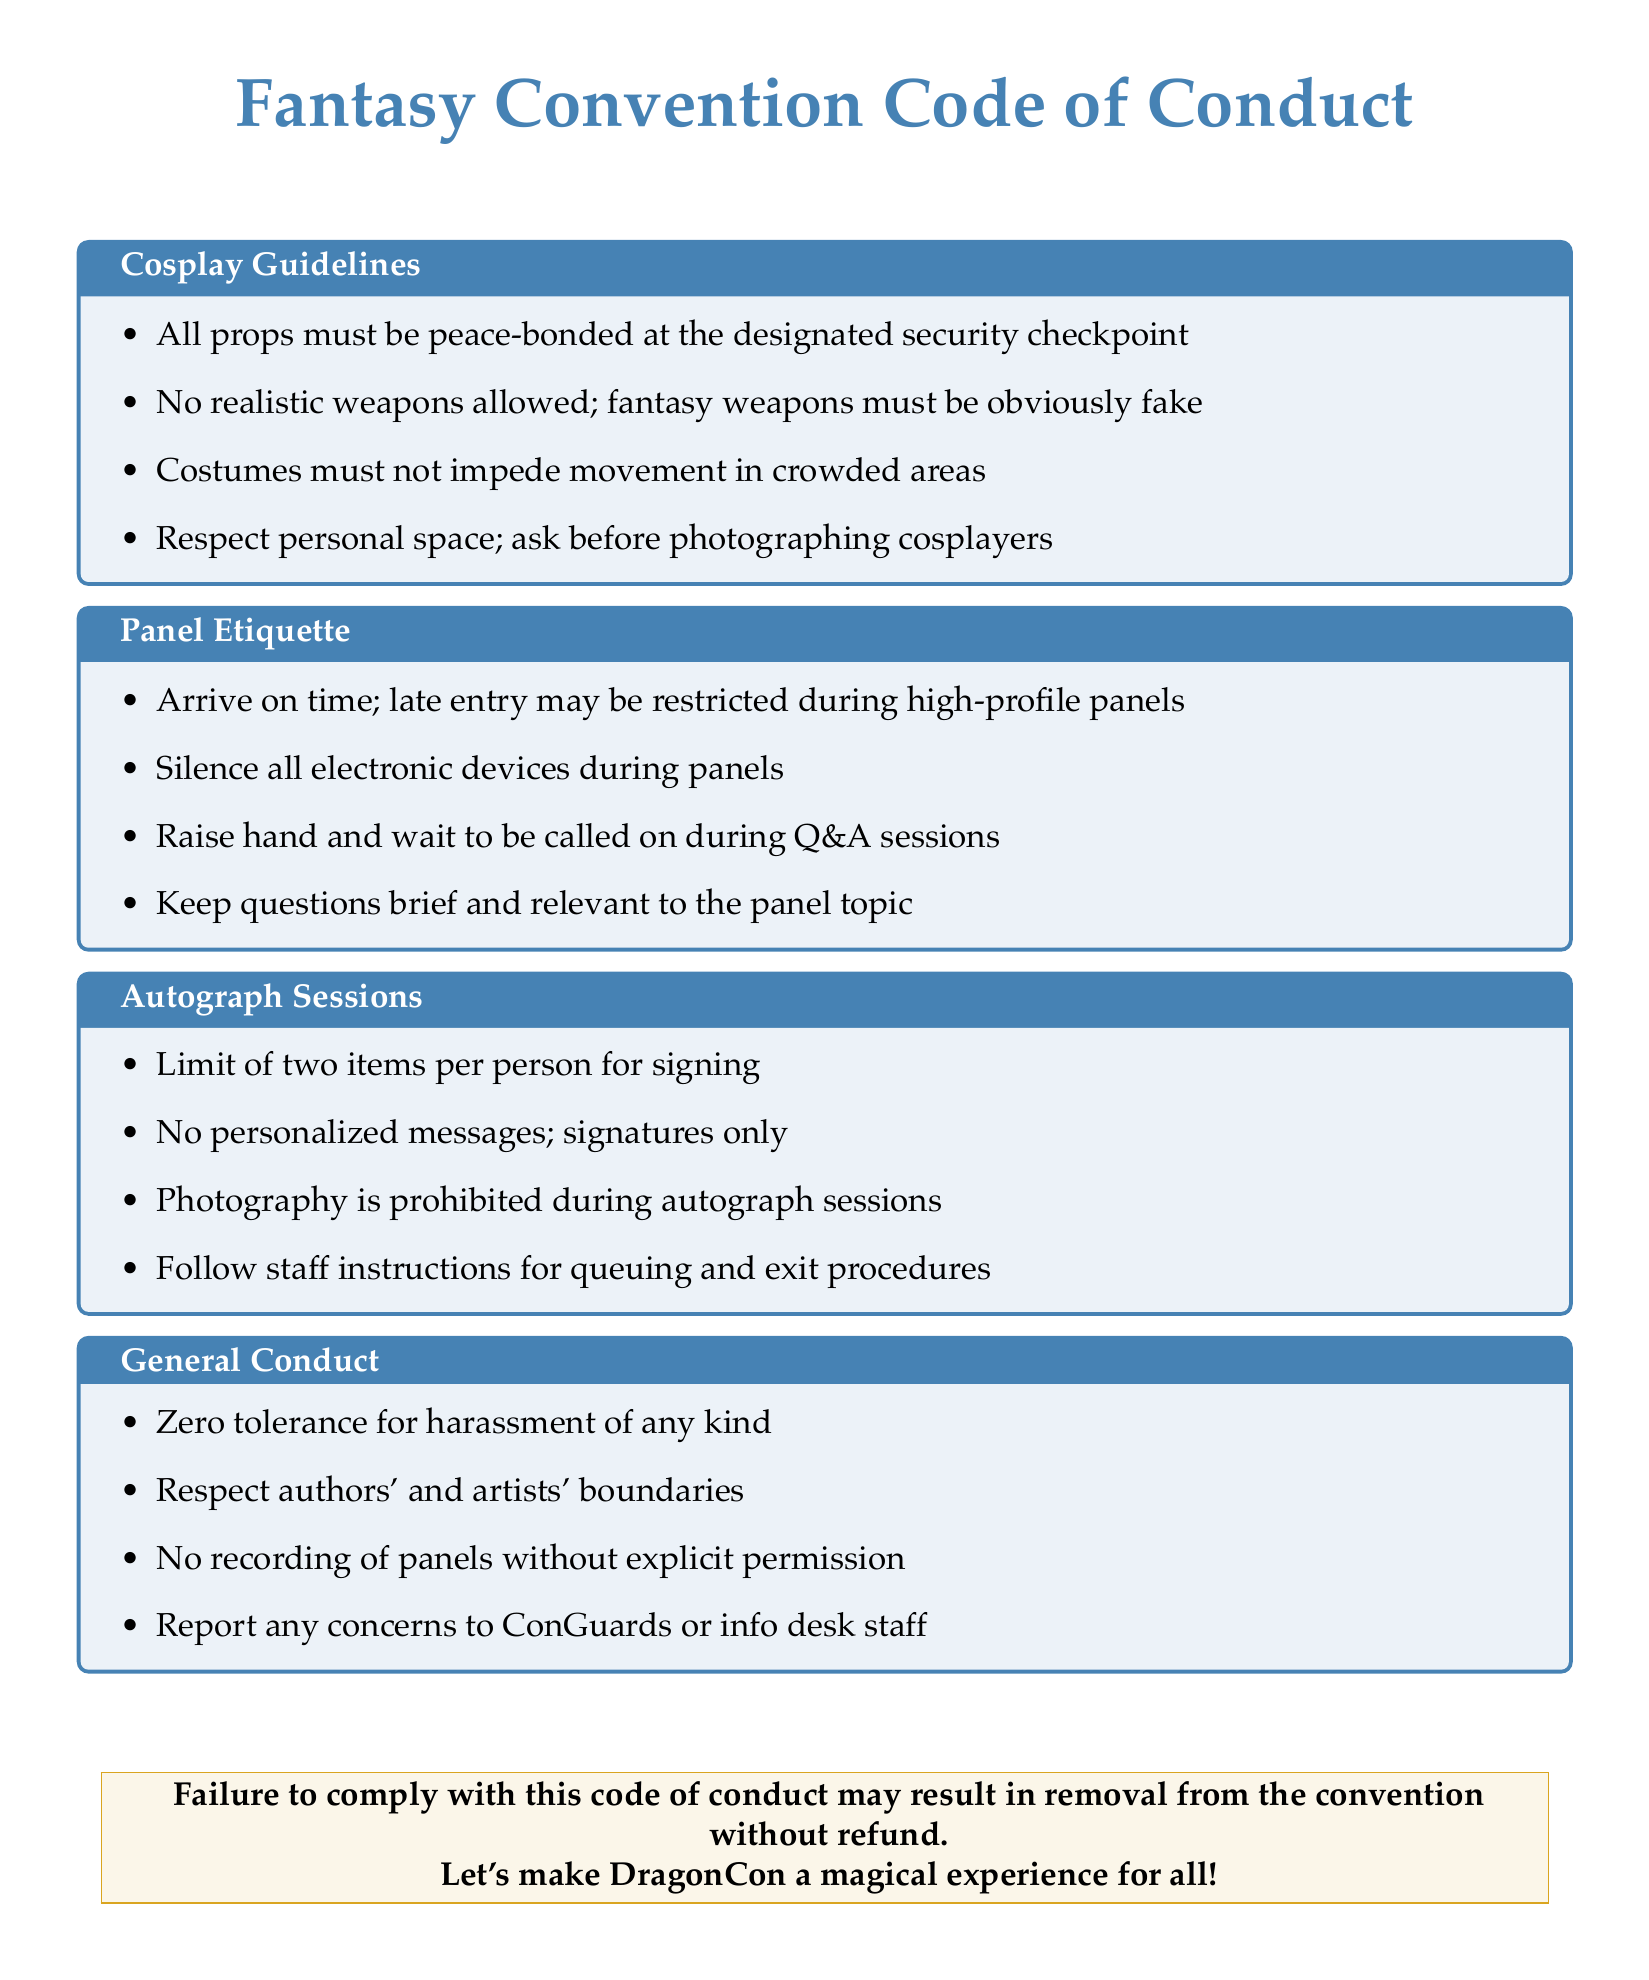What props must be at the designated security checkpoint? The document states that "All props must be peace-bonded at the designated security checkpoint."
Answer: peace-bonded How many items can someone have signed during the autograph session? According to the document, there is a "Limit of two items per person for signing."
Answer: two items Are realistic weapons allowed? The cosplay guidelines specify that "No realistic weapons allowed."
Answer: No What should attendees do with their electronic devices during panels? The panel etiquette section instructs attendees to "Silence all electronic devices during panels."
Answer: Silence What is the consequence of failing to comply with the code of conduct? The document mentions that "Failure to comply with this code of conduct may result in removal from the convention without refund."
Answer: removal from the convention without refund What must a person do before photographing cosplayers? The cosplay guidelines state that you should "ask before photographing cosplayers."
Answer: ask During Q&A sessions, how should attendees request to speak? The panel etiquette advises to "Raise hand and wait to be called on during Q&A sessions."
Answer: Raise hand What is prohibited during autograph sessions? The document clearly states that "Photography is prohibited during autograph sessions."
Answer: Photography 